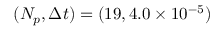Convert formula to latex. <formula><loc_0><loc_0><loc_500><loc_500>( N _ { p } , \Delta t ) = ( 1 9 , 4 . 0 \times 1 0 ^ { - 5 } )</formula> 